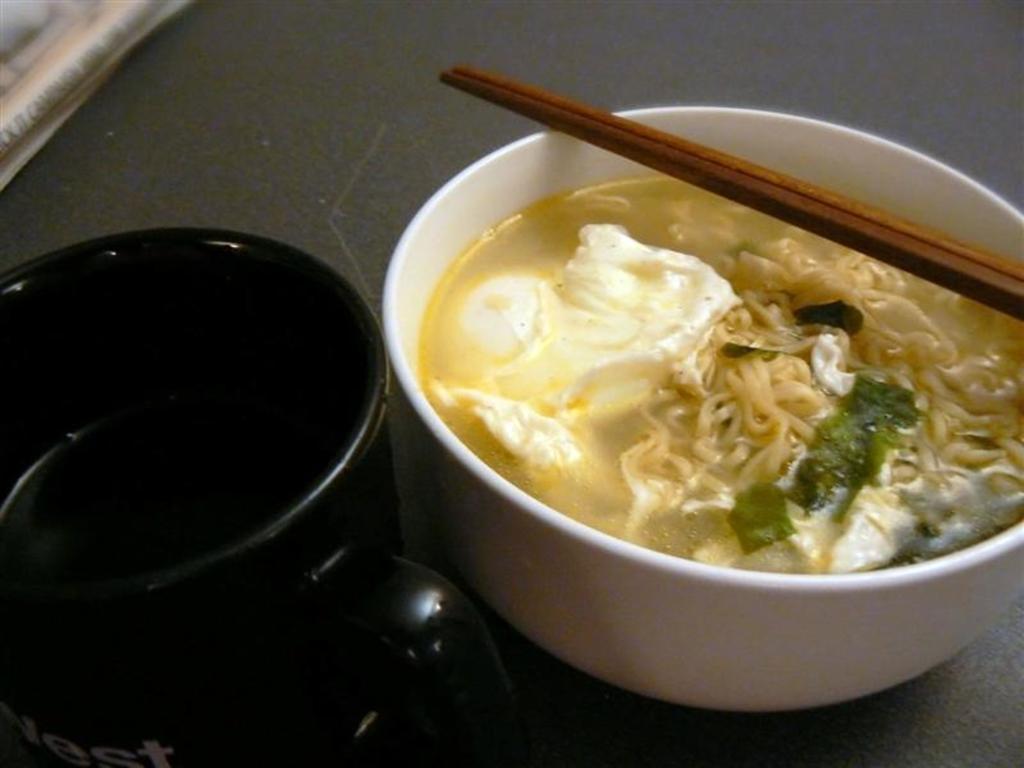Describe this image in one or two sentences. In this picture we can find two bowls. In one bowl there is a soup, noodles and leaf. On the top we can find chopsticks. The bowl is white in colour. 